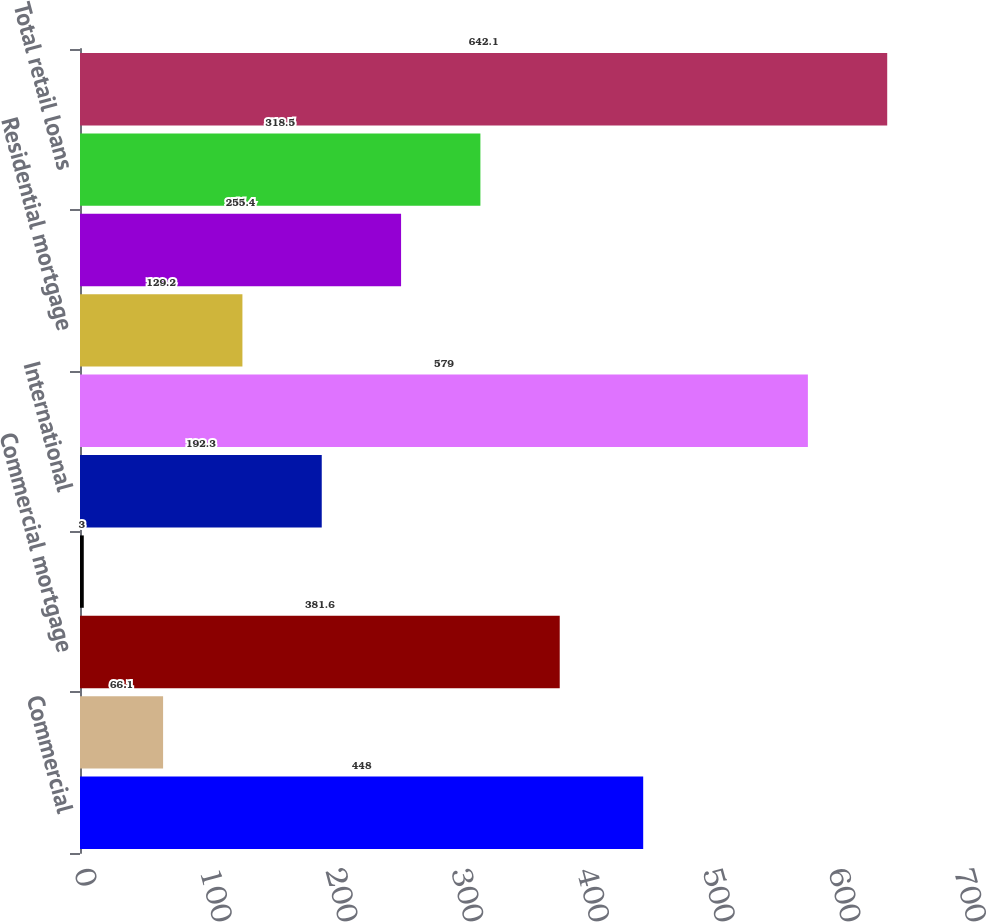<chart> <loc_0><loc_0><loc_500><loc_500><bar_chart><fcel>Commercial<fcel>Real estate construction<fcel>Commercial mortgage<fcel>Lease financing<fcel>International<fcel>Total business loans<fcel>Residential mortgage<fcel>Consumer<fcel>Total retail loans<fcel>Total loans<nl><fcel>448<fcel>66.1<fcel>381.6<fcel>3<fcel>192.3<fcel>579<fcel>129.2<fcel>255.4<fcel>318.5<fcel>642.1<nl></chart> 